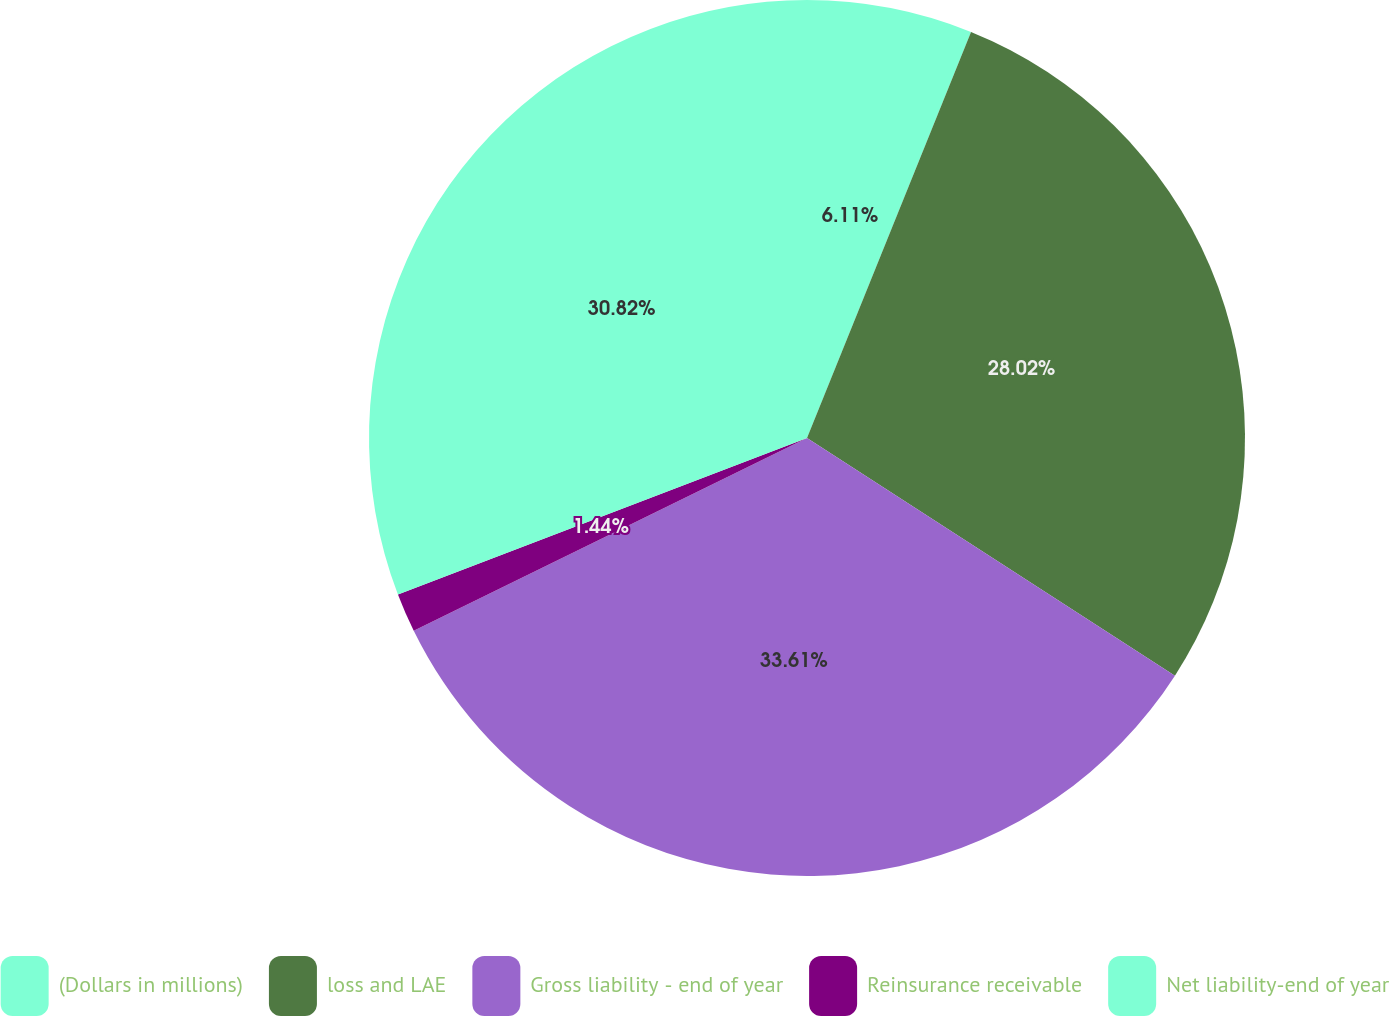Convert chart. <chart><loc_0><loc_0><loc_500><loc_500><pie_chart><fcel>(Dollars in millions)<fcel>loss and LAE<fcel>Gross liability - end of year<fcel>Reinsurance receivable<fcel>Net liability-end of year<nl><fcel>6.11%<fcel>28.02%<fcel>33.62%<fcel>1.44%<fcel>30.82%<nl></chart> 